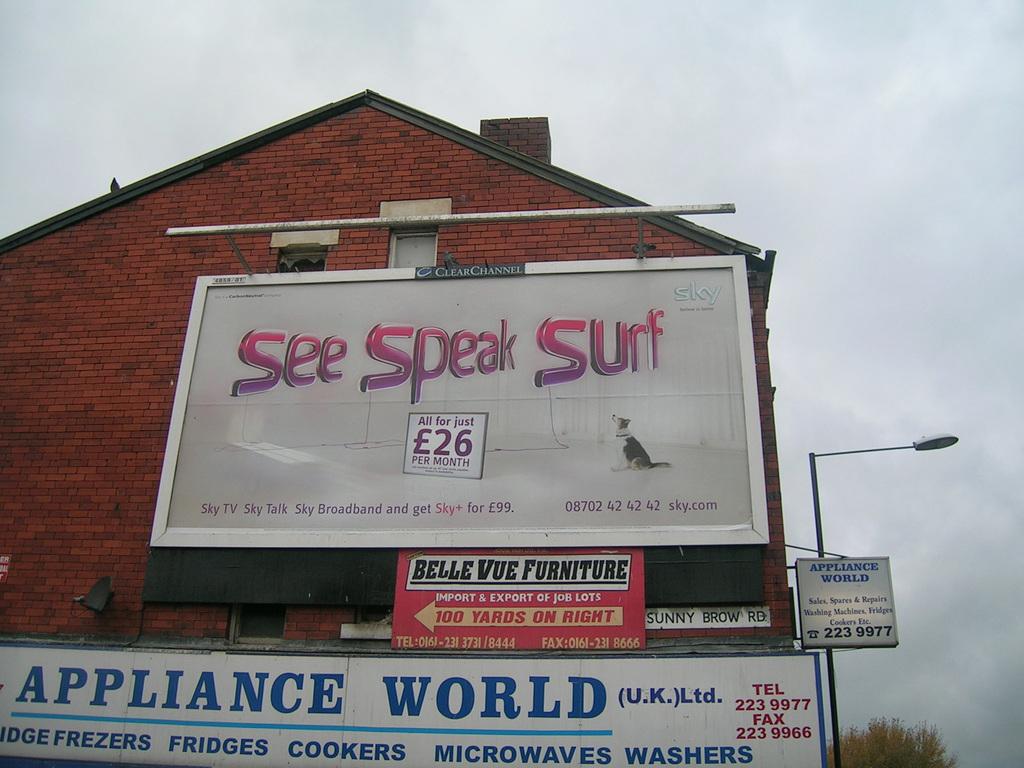What does the store mainly sell?
Your response must be concise. Appliances. 